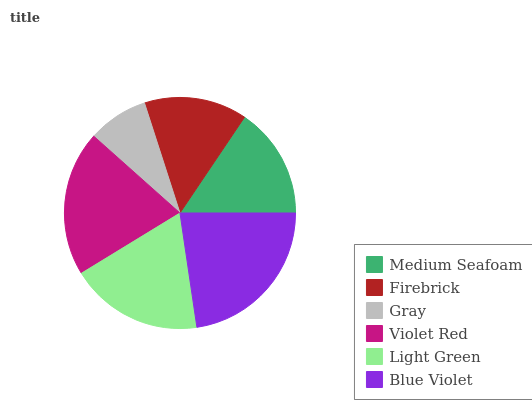Is Gray the minimum?
Answer yes or no. Yes. Is Blue Violet the maximum?
Answer yes or no. Yes. Is Firebrick the minimum?
Answer yes or no. No. Is Firebrick the maximum?
Answer yes or no. No. Is Medium Seafoam greater than Firebrick?
Answer yes or no. Yes. Is Firebrick less than Medium Seafoam?
Answer yes or no. Yes. Is Firebrick greater than Medium Seafoam?
Answer yes or no. No. Is Medium Seafoam less than Firebrick?
Answer yes or no. No. Is Light Green the high median?
Answer yes or no. Yes. Is Medium Seafoam the low median?
Answer yes or no. Yes. Is Medium Seafoam the high median?
Answer yes or no. No. Is Firebrick the low median?
Answer yes or no. No. 